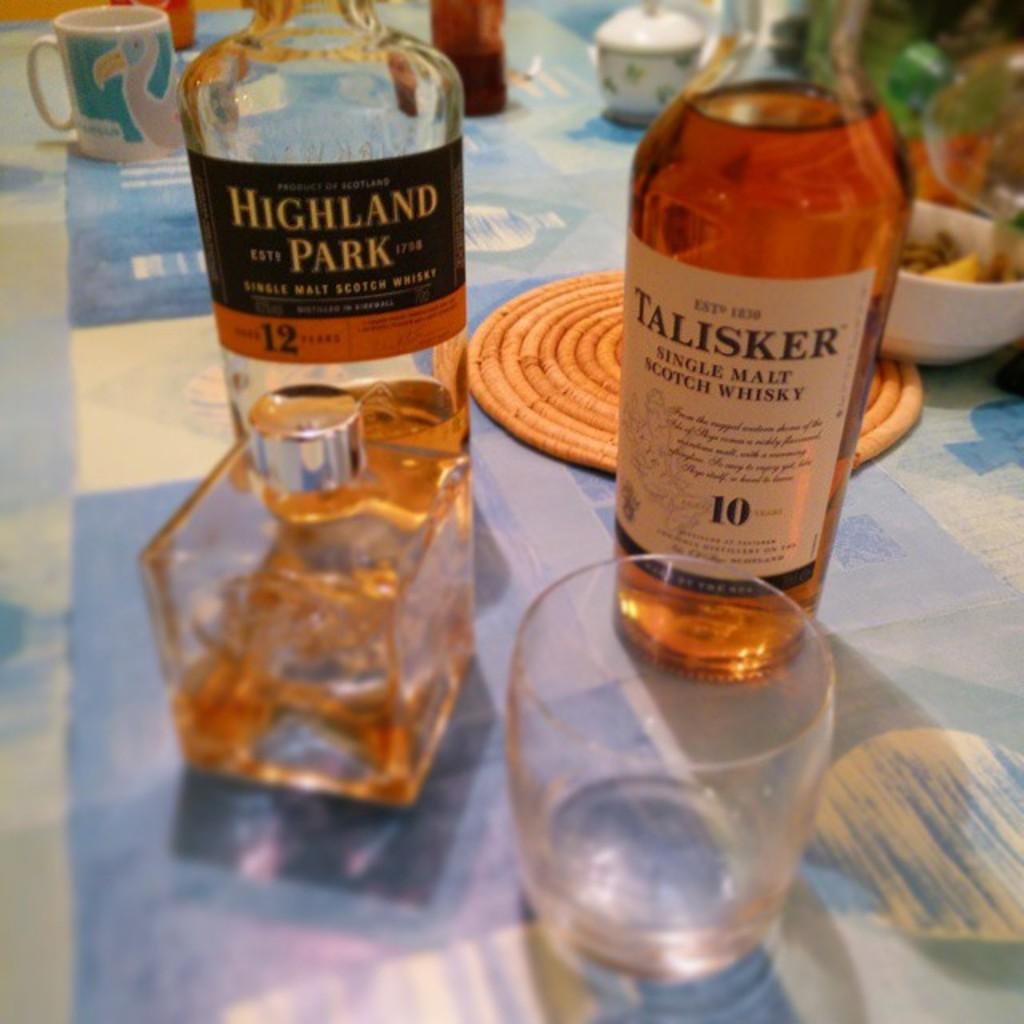What brand is in the bottle on the left?
Your response must be concise. Highland park. What kind of alcoholic liquid is in the bottles on the table?
Your response must be concise. Whiskey. 